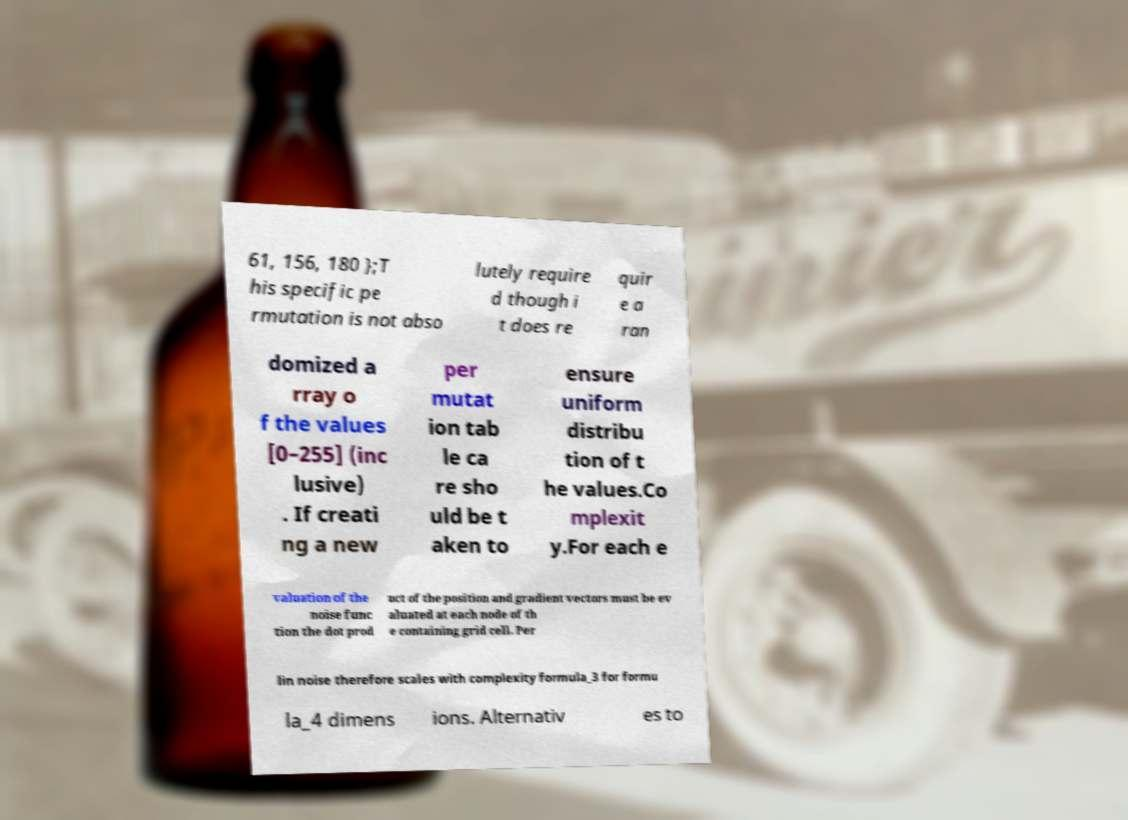There's text embedded in this image that I need extracted. Can you transcribe it verbatim? 61, 156, 180 };T his specific pe rmutation is not abso lutely require d though i t does re quir e a ran domized a rray o f the values [0–255] (inc lusive) . If creati ng a new per mutat ion tab le ca re sho uld be t aken to ensure uniform distribu tion of t he values.Co mplexit y.For each e valuation of the noise func tion the dot prod uct of the position and gradient vectors must be ev aluated at each node of th e containing grid cell. Per lin noise therefore scales with complexity formula_3 for formu la_4 dimens ions. Alternativ es to 